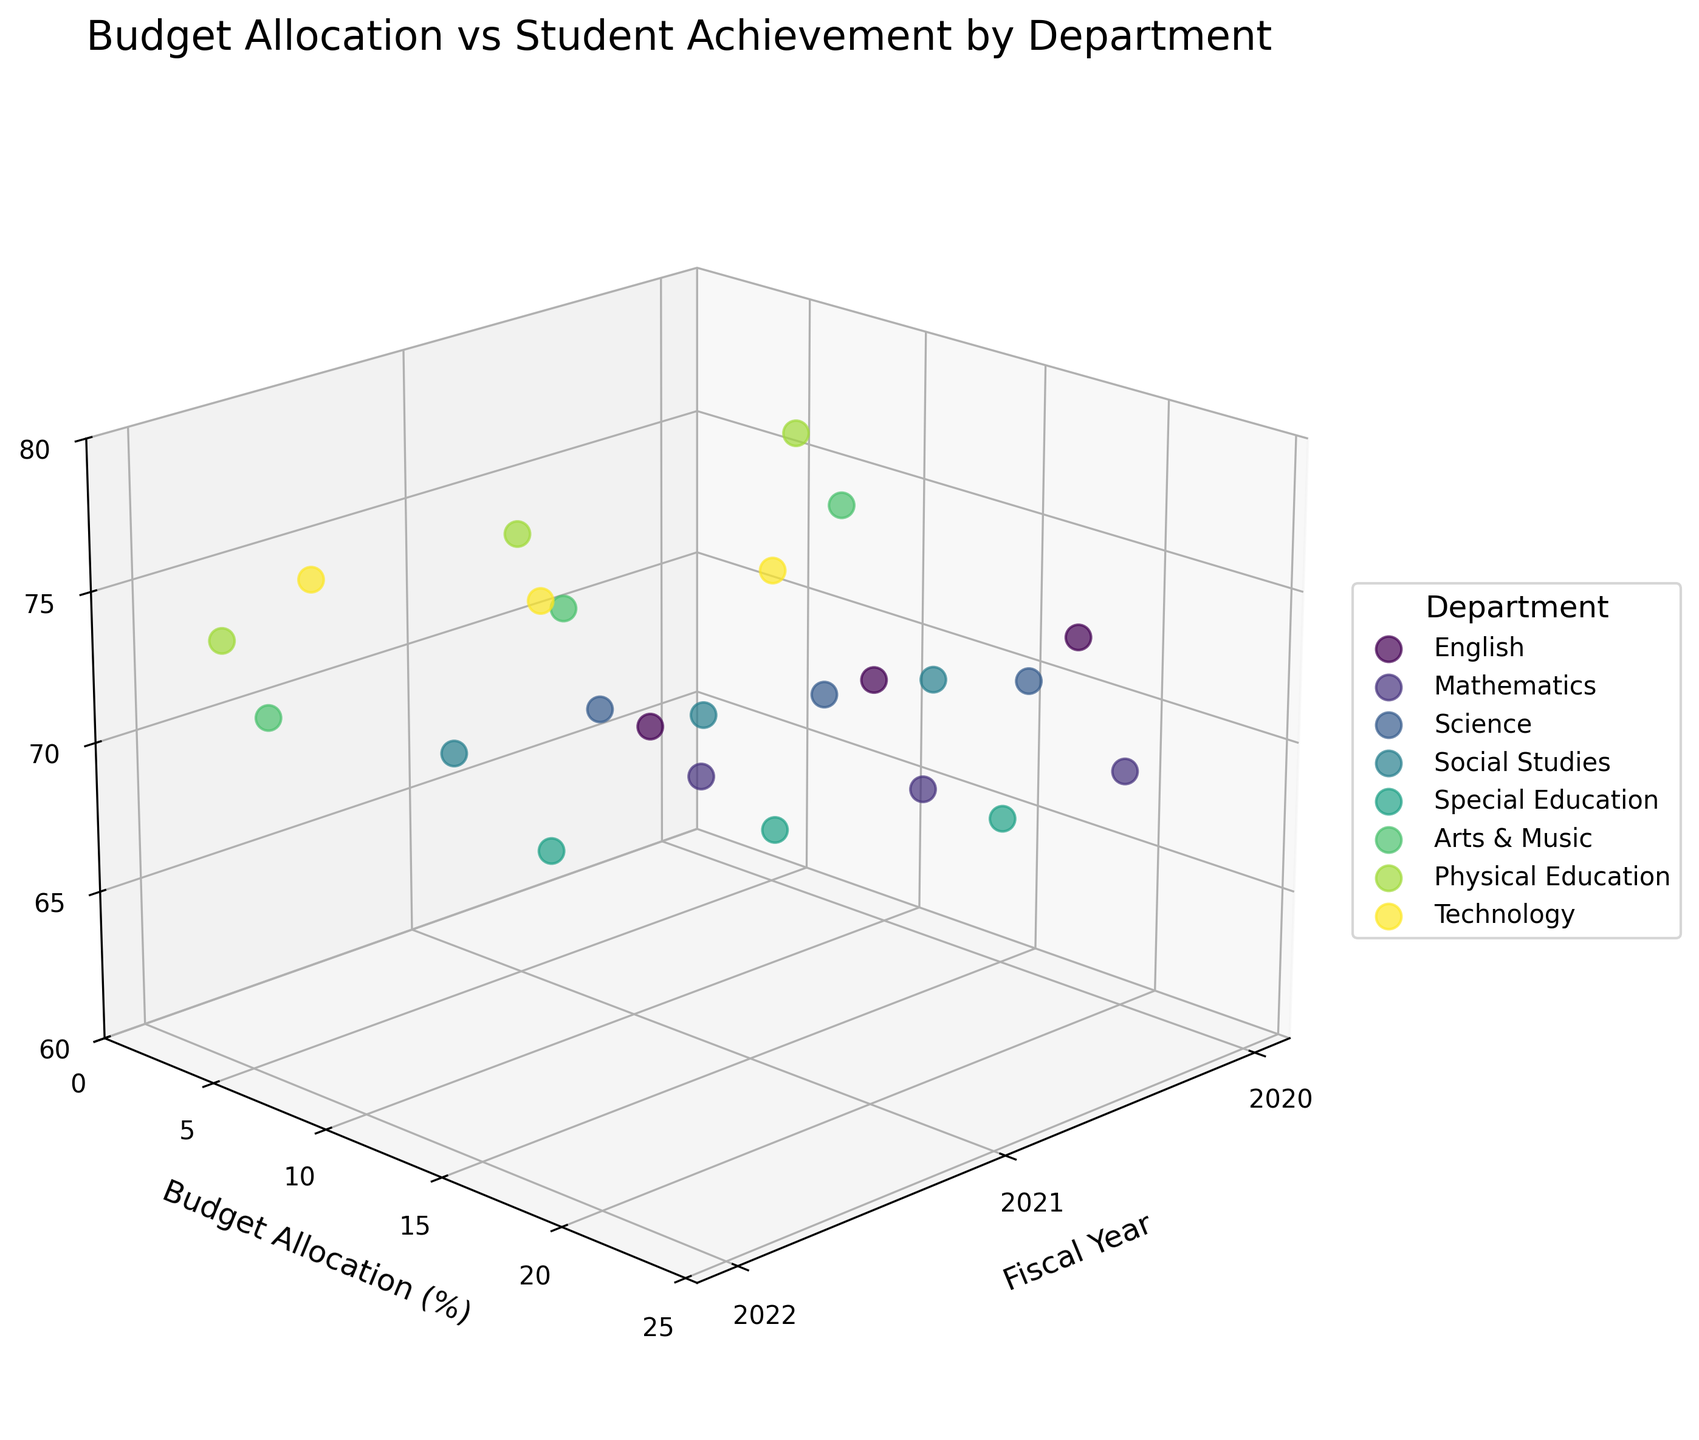How many unique departments are displayed in the plot? The plot legend shows the different departments labeled, each with a distinct color. By counting these labels, you can determine the number of unique departments presented.
Answer: 8 Which department received the highest budget allocation in the fiscal year 2020? By observing the 'Budget Allocation (%)' axis and checking the values for each department in the fiscal year 2020, the highest budget allocation can be identified.
Answer: Mathematics How did the Student Achievement Score change for Science from 2020 to 2022? Locate the Science department's data points in the plot across the fiscal years 2020 to 2022, then observe the change in the 'Student Achievement Score' values. The scores increase from 70 to 76.
Answer: Increased Which two departments had the highest Student Achievement Scores in fiscal year 2022? Identify the data points corresponding to the fiscal year 2022 and check the 'Student Achievement Score' axis to find the two highest scores. Both Physical Education and Technology had the highest scores.
Answer: Physical Education, Technology How does the Budget Allocation (%) correlate with Student Achievement Scores overall? By observing the spread and trend of data points in the plot, you can infer if there's a general increase or decrease in 'Student Achievement Score' with changes in 'Budget Allocation (%)'. Higher budget allocations generally correspond to higher student achievement scores, observed through departments like Mathematics and Science.
Answer: Positive correlation Which department showed a decrease in Budget Allocation (%) from 2020 to 2022? Find the data points for each fiscal year for each department and compare their 'Budget Allocation (%)'. Arts & Music and Physical Education both show a decrease.
Answer: Arts & Music, Physical Education What is the trend in Budget Allocation (%) for the Technology department over the three fiscal years? Look at the data for Technology for the years 2020, 2021, and 2022, and observe the changes in 'Budget Allocation (%)'. The budget allocation increases from 5% to 8%.
Answer: Increasing Which department had the lowest Student Achievement Score in fiscal year 2020 and what is the value? Identify the data points corresponding to the fiscal year 2020 and measure them against the 'Student Achievement Score' axis to find the lowest value. The lowest score for 2020 is in Special Education.
Answer: Special Education, 65 